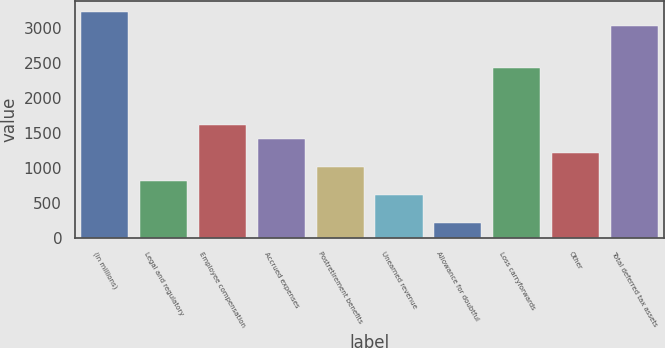Convert chart. <chart><loc_0><loc_0><loc_500><loc_500><bar_chart><fcel>(in millions)<fcel>Legal and regulatory<fcel>Employee compensation<fcel>Accrued expenses<fcel>Postretirement benefits<fcel>Unearned revenue<fcel>Allowance for doubtful<fcel>Loss carryforwards<fcel>Other<fcel>Total deferred tax assets<nl><fcel>3224.8<fcel>809.2<fcel>1614.4<fcel>1413.1<fcel>1010.5<fcel>607.9<fcel>205.3<fcel>2419.6<fcel>1211.8<fcel>3023.5<nl></chart> 